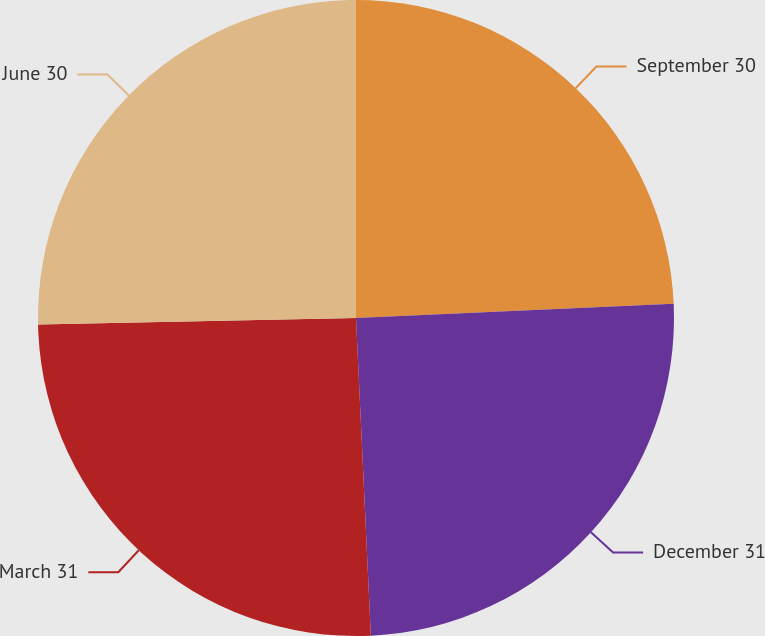Convert chart to OTSL. <chart><loc_0><loc_0><loc_500><loc_500><pie_chart><fcel>September 30<fcel>December 31<fcel>March 31<fcel>June 30<nl><fcel>24.28%<fcel>24.97%<fcel>25.42%<fcel>25.32%<nl></chart> 